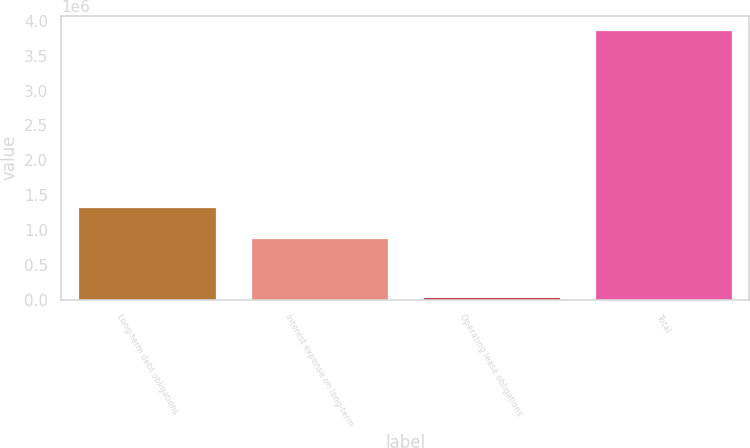Convert chart to OTSL. <chart><loc_0><loc_0><loc_500><loc_500><bar_chart><fcel>Long-term debt obligations<fcel>Interest expense on long-term<fcel>Operating lease obligations<fcel>Total<nl><fcel>1.32207e+06<fcel>889686<fcel>38561<fcel>3.87819e+06<nl></chart> 